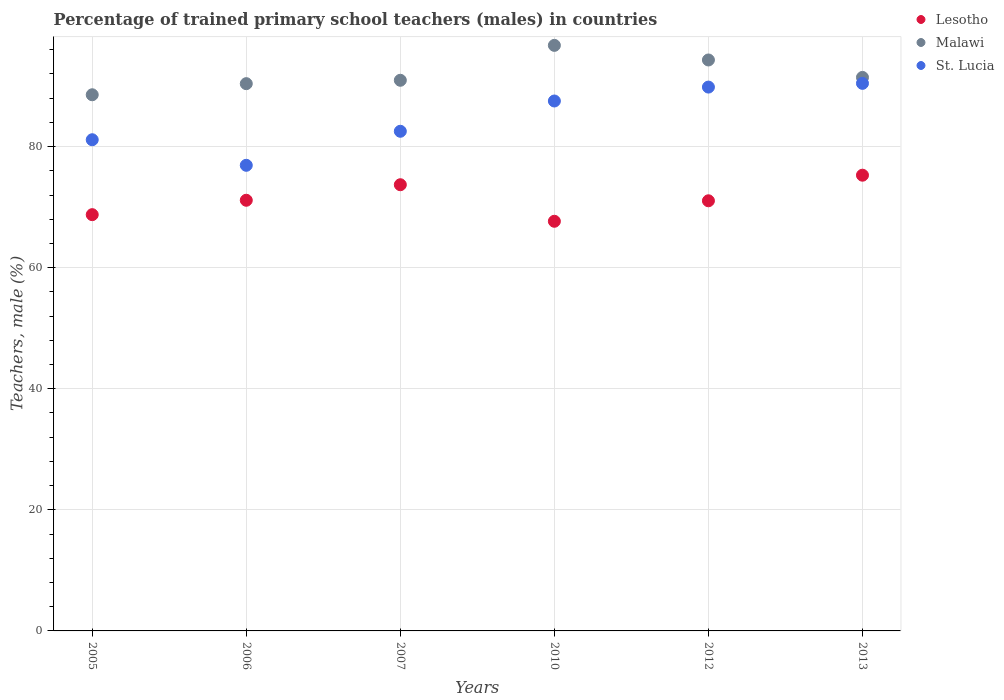How many different coloured dotlines are there?
Keep it short and to the point. 3. Is the number of dotlines equal to the number of legend labels?
Your response must be concise. Yes. What is the percentage of trained primary school teachers (males) in Lesotho in 2012?
Provide a short and direct response. 71.05. Across all years, what is the maximum percentage of trained primary school teachers (males) in Lesotho?
Your answer should be very brief. 75.27. Across all years, what is the minimum percentage of trained primary school teachers (males) in Malawi?
Your response must be concise. 88.56. In which year was the percentage of trained primary school teachers (males) in St. Lucia maximum?
Ensure brevity in your answer.  2013. What is the total percentage of trained primary school teachers (males) in Lesotho in the graph?
Give a very brief answer. 427.56. What is the difference between the percentage of trained primary school teachers (males) in Malawi in 2010 and that in 2012?
Your answer should be very brief. 2.41. What is the difference between the percentage of trained primary school teachers (males) in St. Lucia in 2013 and the percentage of trained primary school teachers (males) in Lesotho in 2010?
Provide a succinct answer. 22.78. What is the average percentage of trained primary school teachers (males) in Lesotho per year?
Your answer should be compact. 71.26. In the year 2007, what is the difference between the percentage of trained primary school teachers (males) in St. Lucia and percentage of trained primary school teachers (males) in Malawi?
Give a very brief answer. -8.42. In how many years, is the percentage of trained primary school teachers (males) in St. Lucia greater than 84 %?
Make the answer very short. 3. What is the ratio of the percentage of trained primary school teachers (males) in Malawi in 2012 to that in 2013?
Ensure brevity in your answer.  1.03. Is the percentage of trained primary school teachers (males) in Lesotho in 2005 less than that in 2013?
Make the answer very short. Yes. What is the difference between the highest and the second highest percentage of trained primary school teachers (males) in Malawi?
Ensure brevity in your answer.  2.41. What is the difference between the highest and the lowest percentage of trained primary school teachers (males) in St. Lucia?
Provide a succinct answer. 13.53. In how many years, is the percentage of trained primary school teachers (males) in Lesotho greater than the average percentage of trained primary school teachers (males) in Lesotho taken over all years?
Ensure brevity in your answer.  2. Is the sum of the percentage of trained primary school teachers (males) in Lesotho in 2010 and 2013 greater than the maximum percentage of trained primary school teachers (males) in Malawi across all years?
Your answer should be very brief. Yes. Is it the case that in every year, the sum of the percentage of trained primary school teachers (males) in St. Lucia and percentage of trained primary school teachers (males) in Lesotho  is greater than the percentage of trained primary school teachers (males) in Malawi?
Keep it short and to the point. Yes. How many dotlines are there?
Provide a succinct answer. 3. How many years are there in the graph?
Offer a terse response. 6. What is the difference between two consecutive major ticks on the Y-axis?
Make the answer very short. 20. Are the values on the major ticks of Y-axis written in scientific E-notation?
Provide a short and direct response. No. Does the graph contain any zero values?
Your response must be concise. No. Does the graph contain grids?
Offer a very short reply. Yes. What is the title of the graph?
Ensure brevity in your answer.  Percentage of trained primary school teachers (males) in countries. What is the label or title of the Y-axis?
Ensure brevity in your answer.  Teachers, male (%). What is the Teachers, male (%) in Lesotho in 2005?
Give a very brief answer. 68.75. What is the Teachers, male (%) in Malawi in 2005?
Your answer should be compact. 88.56. What is the Teachers, male (%) of St. Lucia in 2005?
Offer a terse response. 81.13. What is the Teachers, male (%) in Lesotho in 2006?
Make the answer very short. 71.13. What is the Teachers, male (%) in Malawi in 2006?
Provide a succinct answer. 90.39. What is the Teachers, male (%) of St. Lucia in 2006?
Provide a short and direct response. 76.91. What is the Teachers, male (%) of Lesotho in 2007?
Provide a short and direct response. 73.7. What is the Teachers, male (%) of Malawi in 2007?
Your response must be concise. 90.95. What is the Teachers, male (%) in St. Lucia in 2007?
Make the answer very short. 82.53. What is the Teachers, male (%) in Lesotho in 2010?
Offer a terse response. 67.66. What is the Teachers, male (%) in Malawi in 2010?
Give a very brief answer. 96.72. What is the Teachers, male (%) of St. Lucia in 2010?
Offer a very short reply. 87.53. What is the Teachers, male (%) of Lesotho in 2012?
Offer a very short reply. 71.05. What is the Teachers, male (%) of Malawi in 2012?
Offer a very short reply. 94.3. What is the Teachers, male (%) of St. Lucia in 2012?
Give a very brief answer. 89.82. What is the Teachers, male (%) of Lesotho in 2013?
Give a very brief answer. 75.27. What is the Teachers, male (%) of Malawi in 2013?
Your answer should be compact. 91.42. What is the Teachers, male (%) in St. Lucia in 2013?
Your response must be concise. 90.44. Across all years, what is the maximum Teachers, male (%) in Lesotho?
Ensure brevity in your answer.  75.27. Across all years, what is the maximum Teachers, male (%) of Malawi?
Your answer should be compact. 96.72. Across all years, what is the maximum Teachers, male (%) in St. Lucia?
Make the answer very short. 90.44. Across all years, what is the minimum Teachers, male (%) of Lesotho?
Offer a very short reply. 67.66. Across all years, what is the minimum Teachers, male (%) in Malawi?
Your answer should be compact. 88.56. Across all years, what is the minimum Teachers, male (%) of St. Lucia?
Your response must be concise. 76.91. What is the total Teachers, male (%) in Lesotho in the graph?
Your answer should be compact. 427.56. What is the total Teachers, male (%) in Malawi in the graph?
Make the answer very short. 552.34. What is the total Teachers, male (%) of St. Lucia in the graph?
Your response must be concise. 508.35. What is the difference between the Teachers, male (%) in Lesotho in 2005 and that in 2006?
Provide a short and direct response. -2.38. What is the difference between the Teachers, male (%) of Malawi in 2005 and that in 2006?
Give a very brief answer. -1.83. What is the difference between the Teachers, male (%) in St. Lucia in 2005 and that in 2006?
Provide a succinct answer. 4.22. What is the difference between the Teachers, male (%) of Lesotho in 2005 and that in 2007?
Ensure brevity in your answer.  -4.94. What is the difference between the Teachers, male (%) of Malawi in 2005 and that in 2007?
Your answer should be compact. -2.39. What is the difference between the Teachers, male (%) in St. Lucia in 2005 and that in 2007?
Ensure brevity in your answer.  -1.4. What is the difference between the Teachers, male (%) in Lesotho in 2005 and that in 2010?
Offer a terse response. 1.09. What is the difference between the Teachers, male (%) in Malawi in 2005 and that in 2010?
Offer a very short reply. -8.16. What is the difference between the Teachers, male (%) in St. Lucia in 2005 and that in 2010?
Make the answer very short. -6.4. What is the difference between the Teachers, male (%) in Lesotho in 2005 and that in 2012?
Provide a short and direct response. -2.29. What is the difference between the Teachers, male (%) in Malawi in 2005 and that in 2012?
Provide a short and direct response. -5.75. What is the difference between the Teachers, male (%) of St. Lucia in 2005 and that in 2012?
Make the answer very short. -8.7. What is the difference between the Teachers, male (%) of Lesotho in 2005 and that in 2013?
Your answer should be compact. -6.52. What is the difference between the Teachers, male (%) of Malawi in 2005 and that in 2013?
Your answer should be compact. -2.87. What is the difference between the Teachers, male (%) of St. Lucia in 2005 and that in 2013?
Provide a short and direct response. -9.31. What is the difference between the Teachers, male (%) in Lesotho in 2006 and that in 2007?
Ensure brevity in your answer.  -2.56. What is the difference between the Teachers, male (%) of Malawi in 2006 and that in 2007?
Your response must be concise. -0.56. What is the difference between the Teachers, male (%) in St. Lucia in 2006 and that in 2007?
Your answer should be compact. -5.62. What is the difference between the Teachers, male (%) in Lesotho in 2006 and that in 2010?
Your response must be concise. 3.47. What is the difference between the Teachers, male (%) of Malawi in 2006 and that in 2010?
Give a very brief answer. -6.33. What is the difference between the Teachers, male (%) in St. Lucia in 2006 and that in 2010?
Offer a very short reply. -10.62. What is the difference between the Teachers, male (%) in Lesotho in 2006 and that in 2012?
Give a very brief answer. 0.09. What is the difference between the Teachers, male (%) of Malawi in 2006 and that in 2012?
Offer a very short reply. -3.91. What is the difference between the Teachers, male (%) of St. Lucia in 2006 and that in 2012?
Make the answer very short. -12.92. What is the difference between the Teachers, male (%) in Lesotho in 2006 and that in 2013?
Keep it short and to the point. -4.14. What is the difference between the Teachers, male (%) of Malawi in 2006 and that in 2013?
Keep it short and to the point. -1.03. What is the difference between the Teachers, male (%) in St. Lucia in 2006 and that in 2013?
Offer a terse response. -13.53. What is the difference between the Teachers, male (%) in Lesotho in 2007 and that in 2010?
Give a very brief answer. 6.04. What is the difference between the Teachers, male (%) of Malawi in 2007 and that in 2010?
Give a very brief answer. -5.77. What is the difference between the Teachers, male (%) of St. Lucia in 2007 and that in 2010?
Provide a short and direct response. -5. What is the difference between the Teachers, male (%) of Lesotho in 2007 and that in 2012?
Offer a terse response. 2.65. What is the difference between the Teachers, male (%) of Malawi in 2007 and that in 2012?
Your answer should be very brief. -3.35. What is the difference between the Teachers, male (%) in St. Lucia in 2007 and that in 2012?
Give a very brief answer. -7.3. What is the difference between the Teachers, male (%) of Lesotho in 2007 and that in 2013?
Your response must be concise. -1.57. What is the difference between the Teachers, male (%) of Malawi in 2007 and that in 2013?
Provide a succinct answer. -0.47. What is the difference between the Teachers, male (%) of St. Lucia in 2007 and that in 2013?
Provide a short and direct response. -7.91. What is the difference between the Teachers, male (%) in Lesotho in 2010 and that in 2012?
Offer a terse response. -3.38. What is the difference between the Teachers, male (%) in Malawi in 2010 and that in 2012?
Offer a very short reply. 2.41. What is the difference between the Teachers, male (%) of St. Lucia in 2010 and that in 2012?
Provide a short and direct response. -2.3. What is the difference between the Teachers, male (%) in Lesotho in 2010 and that in 2013?
Offer a very short reply. -7.61. What is the difference between the Teachers, male (%) in Malawi in 2010 and that in 2013?
Ensure brevity in your answer.  5.29. What is the difference between the Teachers, male (%) of St. Lucia in 2010 and that in 2013?
Keep it short and to the point. -2.91. What is the difference between the Teachers, male (%) in Lesotho in 2012 and that in 2013?
Offer a very short reply. -4.23. What is the difference between the Teachers, male (%) of Malawi in 2012 and that in 2013?
Offer a terse response. 2.88. What is the difference between the Teachers, male (%) in St. Lucia in 2012 and that in 2013?
Your response must be concise. -0.62. What is the difference between the Teachers, male (%) in Lesotho in 2005 and the Teachers, male (%) in Malawi in 2006?
Offer a terse response. -21.64. What is the difference between the Teachers, male (%) of Lesotho in 2005 and the Teachers, male (%) of St. Lucia in 2006?
Offer a very short reply. -8.15. What is the difference between the Teachers, male (%) in Malawi in 2005 and the Teachers, male (%) in St. Lucia in 2006?
Your response must be concise. 11.65. What is the difference between the Teachers, male (%) of Lesotho in 2005 and the Teachers, male (%) of Malawi in 2007?
Keep it short and to the point. -22.2. What is the difference between the Teachers, male (%) of Lesotho in 2005 and the Teachers, male (%) of St. Lucia in 2007?
Offer a very short reply. -13.77. What is the difference between the Teachers, male (%) in Malawi in 2005 and the Teachers, male (%) in St. Lucia in 2007?
Your answer should be very brief. 6.03. What is the difference between the Teachers, male (%) in Lesotho in 2005 and the Teachers, male (%) in Malawi in 2010?
Your answer should be very brief. -27.96. What is the difference between the Teachers, male (%) of Lesotho in 2005 and the Teachers, male (%) of St. Lucia in 2010?
Keep it short and to the point. -18.77. What is the difference between the Teachers, male (%) in Malawi in 2005 and the Teachers, male (%) in St. Lucia in 2010?
Keep it short and to the point. 1.03. What is the difference between the Teachers, male (%) of Lesotho in 2005 and the Teachers, male (%) of Malawi in 2012?
Your answer should be very brief. -25.55. What is the difference between the Teachers, male (%) in Lesotho in 2005 and the Teachers, male (%) in St. Lucia in 2012?
Offer a terse response. -21.07. What is the difference between the Teachers, male (%) of Malawi in 2005 and the Teachers, male (%) of St. Lucia in 2012?
Provide a short and direct response. -1.27. What is the difference between the Teachers, male (%) in Lesotho in 2005 and the Teachers, male (%) in Malawi in 2013?
Provide a short and direct response. -22.67. What is the difference between the Teachers, male (%) in Lesotho in 2005 and the Teachers, male (%) in St. Lucia in 2013?
Keep it short and to the point. -21.69. What is the difference between the Teachers, male (%) in Malawi in 2005 and the Teachers, male (%) in St. Lucia in 2013?
Provide a succinct answer. -1.88. What is the difference between the Teachers, male (%) in Lesotho in 2006 and the Teachers, male (%) in Malawi in 2007?
Offer a very short reply. -19.82. What is the difference between the Teachers, male (%) in Lesotho in 2006 and the Teachers, male (%) in St. Lucia in 2007?
Provide a short and direct response. -11.39. What is the difference between the Teachers, male (%) of Malawi in 2006 and the Teachers, male (%) of St. Lucia in 2007?
Offer a very short reply. 7.86. What is the difference between the Teachers, male (%) in Lesotho in 2006 and the Teachers, male (%) in Malawi in 2010?
Your answer should be very brief. -25.58. What is the difference between the Teachers, male (%) of Lesotho in 2006 and the Teachers, male (%) of St. Lucia in 2010?
Provide a short and direct response. -16.39. What is the difference between the Teachers, male (%) in Malawi in 2006 and the Teachers, male (%) in St. Lucia in 2010?
Provide a short and direct response. 2.86. What is the difference between the Teachers, male (%) of Lesotho in 2006 and the Teachers, male (%) of Malawi in 2012?
Your response must be concise. -23.17. What is the difference between the Teachers, male (%) of Lesotho in 2006 and the Teachers, male (%) of St. Lucia in 2012?
Give a very brief answer. -18.69. What is the difference between the Teachers, male (%) in Malawi in 2006 and the Teachers, male (%) in St. Lucia in 2012?
Your answer should be very brief. 0.57. What is the difference between the Teachers, male (%) of Lesotho in 2006 and the Teachers, male (%) of Malawi in 2013?
Your answer should be compact. -20.29. What is the difference between the Teachers, male (%) in Lesotho in 2006 and the Teachers, male (%) in St. Lucia in 2013?
Offer a terse response. -19.31. What is the difference between the Teachers, male (%) of Malawi in 2006 and the Teachers, male (%) of St. Lucia in 2013?
Your answer should be very brief. -0.05. What is the difference between the Teachers, male (%) in Lesotho in 2007 and the Teachers, male (%) in Malawi in 2010?
Your answer should be very brief. -23.02. What is the difference between the Teachers, male (%) in Lesotho in 2007 and the Teachers, male (%) in St. Lucia in 2010?
Ensure brevity in your answer.  -13.83. What is the difference between the Teachers, male (%) in Malawi in 2007 and the Teachers, male (%) in St. Lucia in 2010?
Your answer should be compact. 3.42. What is the difference between the Teachers, male (%) in Lesotho in 2007 and the Teachers, male (%) in Malawi in 2012?
Offer a terse response. -20.61. What is the difference between the Teachers, male (%) of Lesotho in 2007 and the Teachers, male (%) of St. Lucia in 2012?
Provide a short and direct response. -16.13. What is the difference between the Teachers, male (%) of Malawi in 2007 and the Teachers, male (%) of St. Lucia in 2012?
Make the answer very short. 1.12. What is the difference between the Teachers, male (%) of Lesotho in 2007 and the Teachers, male (%) of Malawi in 2013?
Offer a very short reply. -17.73. What is the difference between the Teachers, male (%) in Lesotho in 2007 and the Teachers, male (%) in St. Lucia in 2013?
Keep it short and to the point. -16.74. What is the difference between the Teachers, male (%) in Malawi in 2007 and the Teachers, male (%) in St. Lucia in 2013?
Your answer should be compact. 0.51. What is the difference between the Teachers, male (%) of Lesotho in 2010 and the Teachers, male (%) of Malawi in 2012?
Your response must be concise. -26.64. What is the difference between the Teachers, male (%) of Lesotho in 2010 and the Teachers, male (%) of St. Lucia in 2012?
Your response must be concise. -22.16. What is the difference between the Teachers, male (%) in Malawi in 2010 and the Teachers, male (%) in St. Lucia in 2012?
Your response must be concise. 6.89. What is the difference between the Teachers, male (%) of Lesotho in 2010 and the Teachers, male (%) of Malawi in 2013?
Provide a succinct answer. -23.76. What is the difference between the Teachers, male (%) in Lesotho in 2010 and the Teachers, male (%) in St. Lucia in 2013?
Offer a terse response. -22.78. What is the difference between the Teachers, male (%) of Malawi in 2010 and the Teachers, male (%) of St. Lucia in 2013?
Make the answer very short. 6.27. What is the difference between the Teachers, male (%) of Lesotho in 2012 and the Teachers, male (%) of Malawi in 2013?
Ensure brevity in your answer.  -20.38. What is the difference between the Teachers, male (%) of Lesotho in 2012 and the Teachers, male (%) of St. Lucia in 2013?
Give a very brief answer. -19.39. What is the difference between the Teachers, male (%) of Malawi in 2012 and the Teachers, male (%) of St. Lucia in 2013?
Ensure brevity in your answer.  3.86. What is the average Teachers, male (%) of Lesotho per year?
Provide a short and direct response. 71.26. What is the average Teachers, male (%) in Malawi per year?
Your response must be concise. 92.06. What is the average Teachers, male (%) of St. Lucia per year?
Your response must be concise. 84.73. In the year 2005, what is the difference between the Teachers, male (%) of Lesotho and Teachers, male (%) of Malawi?
Keep it short and to the point. -19.8. In the year 2005, what is the difference between the Teachers, male (%) in Lesotho and Teachers, male (%) in St. Lucia?
Offer a terse response. -12.37. In the year 2005, what is the difference between the Teachers, male (%) in Malawi and Teachers, male (%) in St. Lucia?
Keep it short and to the point. 7.43. In the year 2006, what is the difference between the Teachers, male (%) of Lesotho and Teachers, male (%) of Malawi?
Offer a very short reply. -19.26. In the year 2006, what is the difference between the Teachers, male (%) in Lesotho and Teachers, male (%) in St. Lucia?
Provide a short and direct response. -5.77. In the year 2006, what is the difference between the Teachers, male (%) of Malawi and Teachers, male (%) of St. Lucia?
Give a very brief answer. 13.48. In the year 2007, what is the difference between the Teachers, male (%) in Lesotho and Teachers, male (%) in Malawi?
Ensure brevity in your answer.  -17.25. In the year 2007, what is the difference between the Teachers, male (%) of Lesotho and Teachers, male (%) of St. Lucia?
Offer a very short reply. -8.83. In the year 2007, what is the difference between the Teachers, male (%) of Malawi and Teachers, male (%) of St. Lucia?
Your answer should be compact. 8.42. In the year 2010, what is the difference between the Teachers, male (%) of Lesotho and Teachers, male (%) of Malawi?
Your answer should be compact. -29.05. In the year 2010, what is the difference between the Teachers, male (%) of Lesotho and Teachers, male (%) of St. Lucia?
Your answer should be very brief. -19.87. In the year 2010, what is the difference between the Teachers, male (%) in Malawi and Teachers, male (%) in St. Lucia?
Your response must be concise. 9.19. In the year 2012, what is the difference between the Teachers, male (%) in Lesotho and Teachers, male (%) in Malawi?
Offer a terse response. -23.26. In the year 2012, what is the difference between the Teachers, male (%) of Lesotho and Teachers, male (%) of St. Lucia?
Your answer should be very brief. -18.78. In the year 2012, what is the difference between the Teachers, male (%) of Malawi and Teachers, male (%) of St. Lucia?
Your answer should be compact. 4.48. In the year 2013, what is the difference between the Teachers, male (%) of Lesotho and Teachers, male (%) of Malawi?
Your response must be concise. -16.15. In the year 2013, what is the difference between the Teachers, male (%) in Lesotho and Teachers, male (%) in St. Lucia?
Give a very brief answer. -15.17. What is the ratio of the Teachers, male (%) of Lesotho in 2005 to that in 2006?
Offer a very short reply. 0.97. What is the ratio of the Teachers, male (%) in Malawi in 2005 to that in 2006?
Ensure brevity in your answer.  0.98. What is the ratio of the Teachers, male (%) of St. Lucia in 2005 to that in 2006?
Make the answer very short. 1.05. What is the ratio of the Teachers, male (%) in Lesotho in 2005 to that in 2007?
Your answer should be compact. 0.93. What is the ratio of the Teachers, male (%) in Malawi in 2005 to that in 2007?
Your answer should be compact. 0.97. What is the ratio of the Teachers, male (%) of St. Lucia in 2005 to that in 2007?
Make the answer very short. 0.98. What is the ratio of the Teachers, male (%) of Lesotho in 2005 to that in 2010?
Your answer should be compact. 1.02. What is the ratio of the Teachers, male (%) of Malawi in 2005 to that in 2010?
Give a very brief answer. 0.92. What is the ratio of the Teachers, male (%) in St. Lucia in 2005 to that in 2010?
Your response must be concise. 0.93. What is the ratio of the Teachers, male (%) of Malawi in 2005 to that in 2012?
Give a very brief answer. 0.94. What is the ratio of the Teachers, male (%) in St. Lucia in 2005 to that in 2012?
Offer a terse response. 0.9. What is the ratio of the Teachers, male (%) in Lesotho in 2005 to that in 2013?
Your answer should be very brief. 0.91. What is the ratio of the Teachers, male (%) of Malawi in 2005 to that in 2013?
Provide a succinct answer. 0.97. What is the ratio of the Teachers, male (%) in St. Lucia in 2005 to that in 2013?
Give a very brief answer. 0.9. What is the ratio of the Teachers, male (%) of Lesotho in 2006 to that in 2007?
Your answer should be compact. 0.97. What is the ratio of the Teachers, male (%) in St. Lucia in 2006 to that in 2007?
Your answer should be very brief. 0.93. What is the ratio of the Teachers, male (%) in Lesotho in 2006 to that in 2010?
Provide a short and direct response. 1.05. What is the ratio of the Teachers, male (%) of Malawi in 2006 to that in 2010?
Provide a short and direct response. 0.93. What is the ratio of the Teachers, male (%) in St. Lucia in 2006 to that in 2010?
Ensure brevity in your answer.  0.88. What is the ratio of the Teachers, male (%) in Malawi in 2006 to that in 2012?
Offer a terse response. 0.96. What is the ratio of the Teachers, male (%) in St. Lucia in 2006 to that in 2012?
Keep it short and to the point. 0.86. What is the ratio of the Teachers, male (%) of Lesotho in 2006 to that in 2013?
Offer a terse response. 0.94. What is the ratio of the Teachers, male (%) of Malawi in 2006 to that in 2013?
Ensure brevity in your answer.  0.99. What is the ratio of the Teachers, male (%) of St. Lucia in 2006 to that in 2013?
Your response must be concise. 0.85. What is the ratio of the Teachers, male (%) of Lesotho in 2007 to that in 2010?
Provide a short and direct response. 1.09. What is the ratio of the Teachers, male (%) of Malawi in 2007 to that in 2010?
Offer a terse response. 0.94. What is the ratio of the Teachers, male (%) in St. Lucia in 2007 to that in 2010?
Give a very brief answer. 0.94. What is the ratio of the Teachers, male (%) of Lesotho in 2007 to that in 2012?
Your response must be concise. 1.04. What is the ratio of the Teachers, male (%) in Malawi in 2007 to that in 2012?
Your answer should be very brief. 0.96. What is the ratio of the Teachers, male (%) in St. Lucia in 2007 to that in 2012?
Your answer should be very brief. 0.92. What is the ratio of the Teachers, male (%) in Lesotho in 2007 to that in 2013?
Make the answer very short. 0.98. What is the ratio of the Teachers, male (%) in St. Lucia in 2007 to that in 2013?
Give a very brief answer. 0.91. What is the ratio of the Teachers, male (%) of Lesotho in 2010 to that in 2012?
Your answer should be compact. 0.95. What is the ratio of the Teachers, male (%) in Malawi in 2010 to that in 2012?
Your response must be concise. 1.03. What is the ratio of the Teachers, male (%) of St. Lucia in 2010 to that in 2012?
Your answer should be very brief. 0.97. What is the ratio of the Teachers, male (%) in Lesotho in 2010 to that in 2013?
Your answer should be very brief. 0.9. What is the ratio of the Teachers, male (%) in Malawi in 2010 to that in 2013?
Your answer should be compact. 1.06. What is the ratio of the Teachers, male (%) in St. Lucia in 2010 to that in 2013?
Your answer should be compact. 0.97. What is the ratio of the Teachers, male (%) of Lesotho in 2012 to that in 2013?
Offer a terse response. 0.94. What is the ratio of the Teachers, male (%) in Malawi in 2012 to that in 2013?
Your response must be concise. 1.03. What is the difference between the highest and the second highest Teachers, male (%) of Lesotho?
Provide a short and direct response. 1.57. What is the difference between the highest and the second highest Teachers, male (%) in Malawi?
Offer a terse response. 2.41. What is the difference between the highest and the second highest Teachers, male (%) in St. Lucia?
Offer a very short reply. 0.62. What is the difference between the highest and the lowest Teachers, male (%) in Lesotho?
Make the answer very short. 7.61. What is the difference between the highest and the lowest Teachers, male (%) in Malawi?
Keep it short and to the point. 8.16. What is the difference between the highest and the lowest Teachers, male (%) of St. Lucia?
Provide a succinct answer. 13.53. 